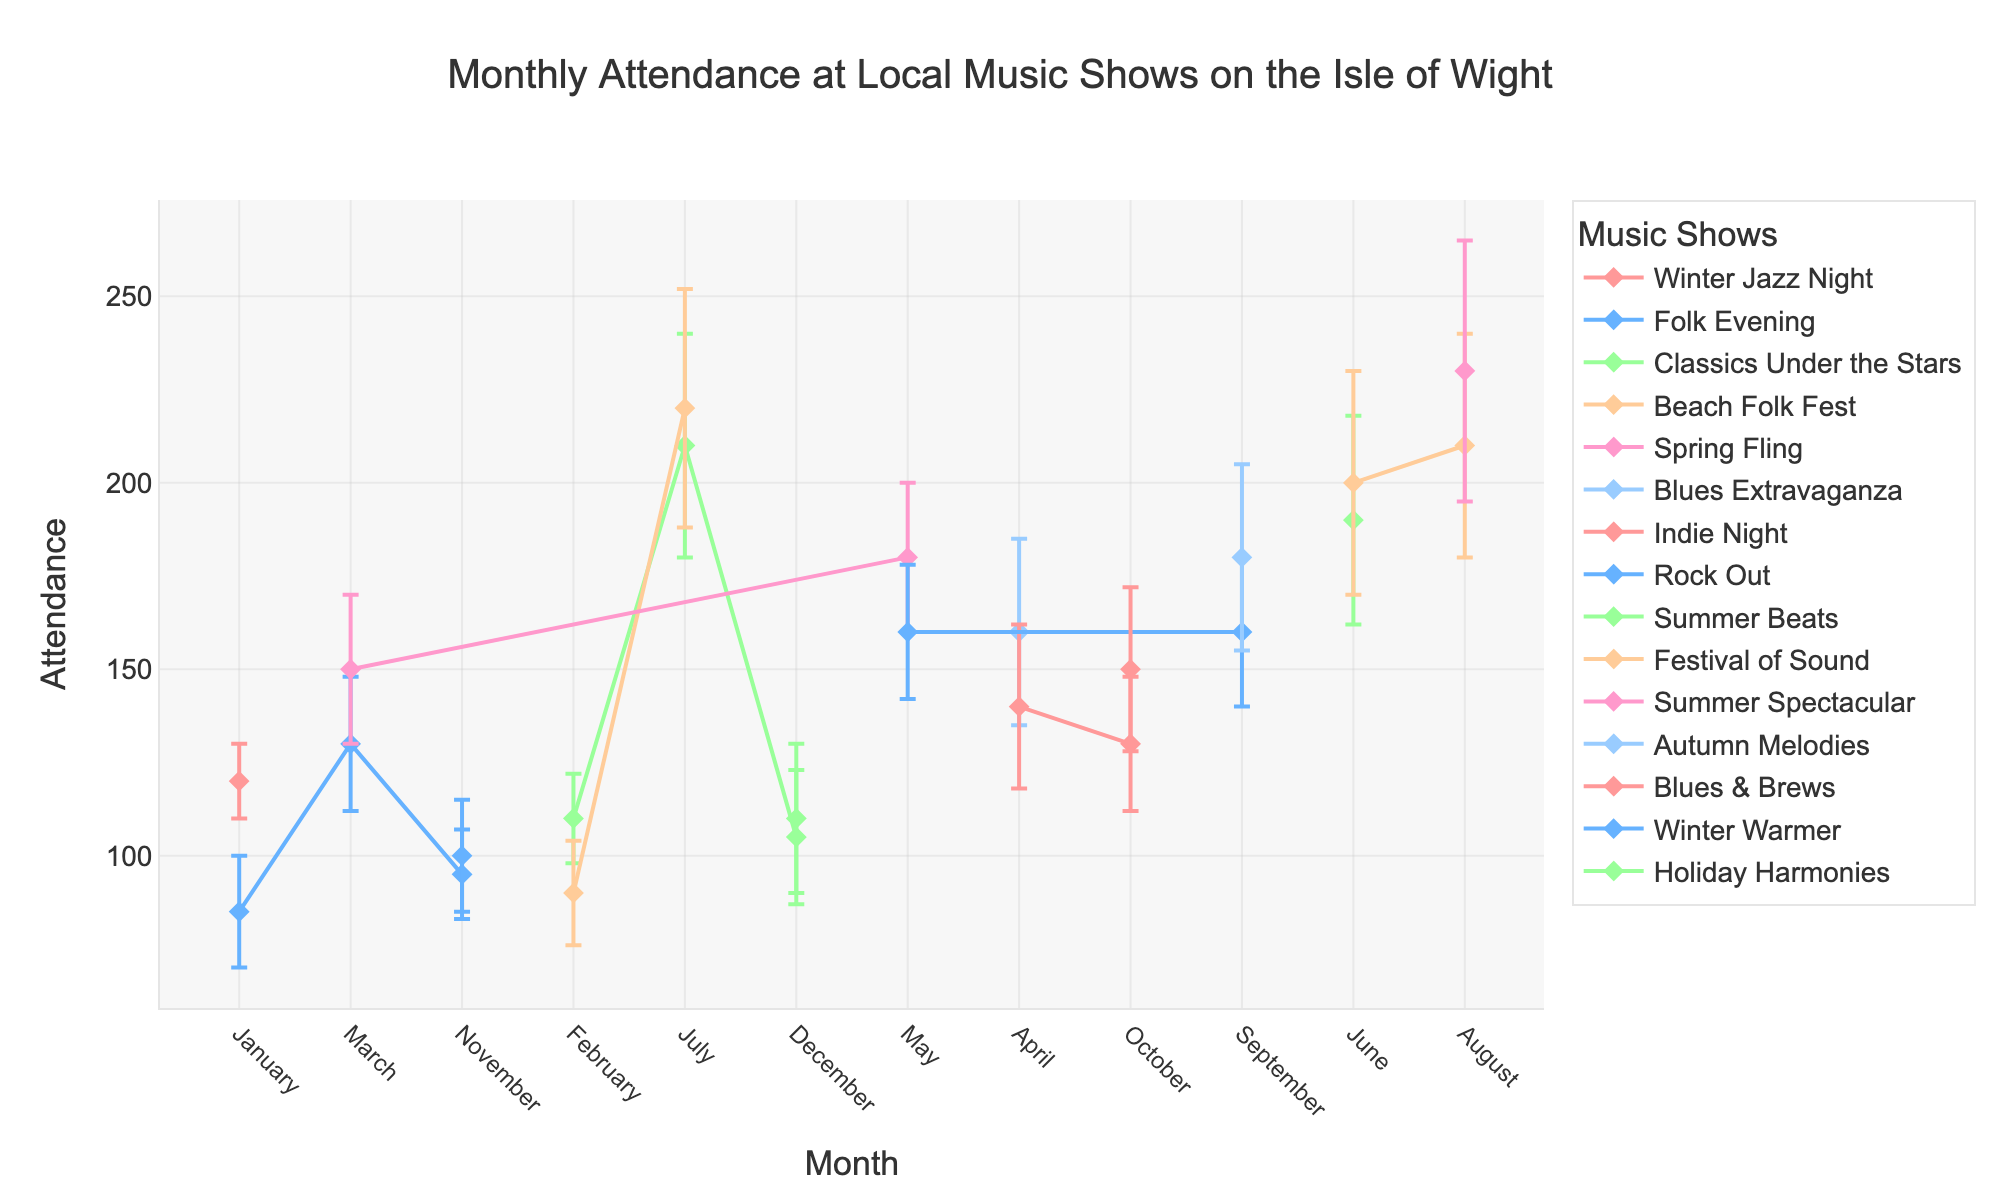What's the title of the figure? The title of the figure is usually located at the top center of the chart. In this figure, it reads "Monthly Attendance at Local Music Shows on the Isle of Wight".
Answer: Monthly Attendance at Local Music Shows on the Isle of Wight What is the average attendance at the "Spring Fling" events in March and May? Find the attendance figures for "Spring Fling" in March and May (150 and 180, respectively). Add these two values together and then divide by 2: (150 + 180) / 2
Answer: 165 Which month had the highest attendance for "Beach Folk Fest"? Look at the attendance figures for "Beach Folk Fest" across different months. The highest value is in July with 220 attendees.
Answer: July How does the attendance in August compare to July for "Classics Under the Stars"? Check the attendance figures for "Classics Under the Stars" in July (210) and August (no data point in August). Since there’s no data for August, attendance comparison is impossible.
Answer: Cannot compare What is the range of attendance values for "Indie Night"? Find the attendance figures for "Indie Night" across different months: 140 in April, 130 in October. The difference between the highest and lowest values: 140 - 130
Answer: 10 Which event has the highest average attendance across all months? Calculate the average attendance for each event by summing their attendance figures and dividing by the number of months in which they occur. "Summer Spectacular" in August has an average of 230 because it appears only once with this figure, which is the highest among events.
Answer: Summer Spectacular What is the maximum standard deviation in the data, and which event does it correspond to? Look at the "Standard Deviation" column to find the maximum value, which is 35, corresponding to "Summer Spectacular" in August.
Answer: 35 for Summer Spectacular in August How did the attendance for "Rock Out" change from May to September? Check the attendance figures for "Rock Out" in May (160) and September (160). The attendance remained the same between these two months.
Answer: No change Which month shows the greatest variability in attendance and what is the overall standard deviation value for that month? Find the month with the highest standard deviation in attendance. April has a standard deviation of 25 (for "Blues Extravaganza") and 22 (for "Indie Night"). To confirm the highest variability, check if there’s a higher value in another month. June has deviations of 30 and 28, making it have the greatest variability.
Answer: June with std deviations of 30 and 28 